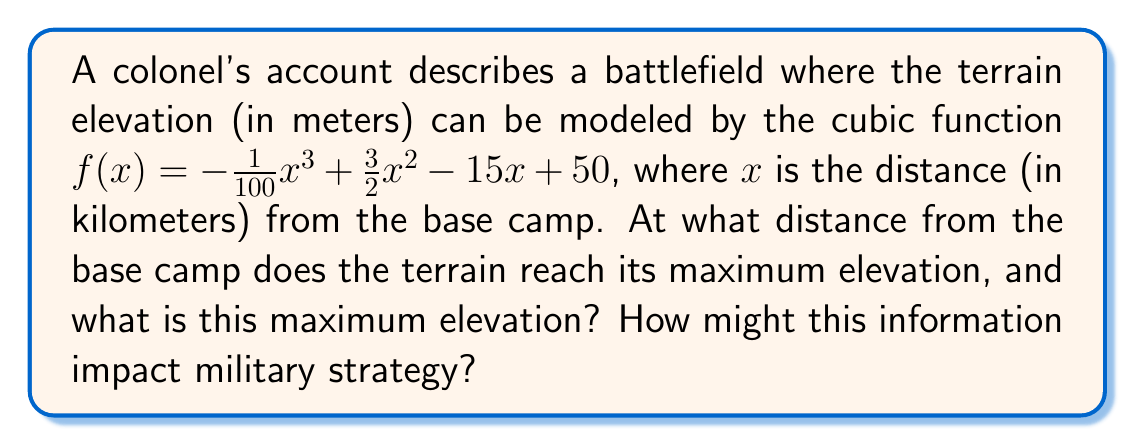Solve this math problem. To find the maximum elevation and its location, we need to follow these steps:

1) Find the derivative of the function:
   $f'(x) = -\frac{3}{100}x^2 + 3x - 15$

2) Set the derivative equal to zero to find critical points:
   $-\frac{3}{100}x^2 + 3x - 15 = 0$

3) Solve this quadratic equation:
   $-3x^2 + 300x - 1500 = 0$
   $x = \frac{-b \pm \sqrt{b^2 - 4ac}}{2a}$
   $x = \frac{-300 \pm \sqrt{300^2 - 4(-3)(-1500)}}{2(-3)}$
   $x = \frac{-300 \pm \sqrt{90000 - 18000}}{-6}$
   $x = \frac{-300 \pm \sqrt{72000}}{-6}$
   $x = \frac{-300 \pm 268.33}{-6}$

   This gives us two solutions:
   $x_1 = 10$ km and $x_2 = 94.72$ km

4) The second derivative test confirms that $x = 10$ km is a maximum:
   $f''(x) = -\frac{6}{100}x + 3$
   $f''(10) = -0.6 + 3 = 2.4 > 0$

5) Calculate the maximum elevation:
   $f(10) = -\frac{1}{100}(10^3) + \frac{3}{2}(10^2) - 15(10) + 50$
   $= -10 + 150 - 150 + 50 = 40$ meters

This information impacts military strategy by revealing the highest point of the terrain, which could be used for surveillance or as a defensive position. The gradual incline from 0 to 10 km might affect troop movements and vehicle deployment.
Answer: Maximum elevation: 40 meters at 10 km from base camp 